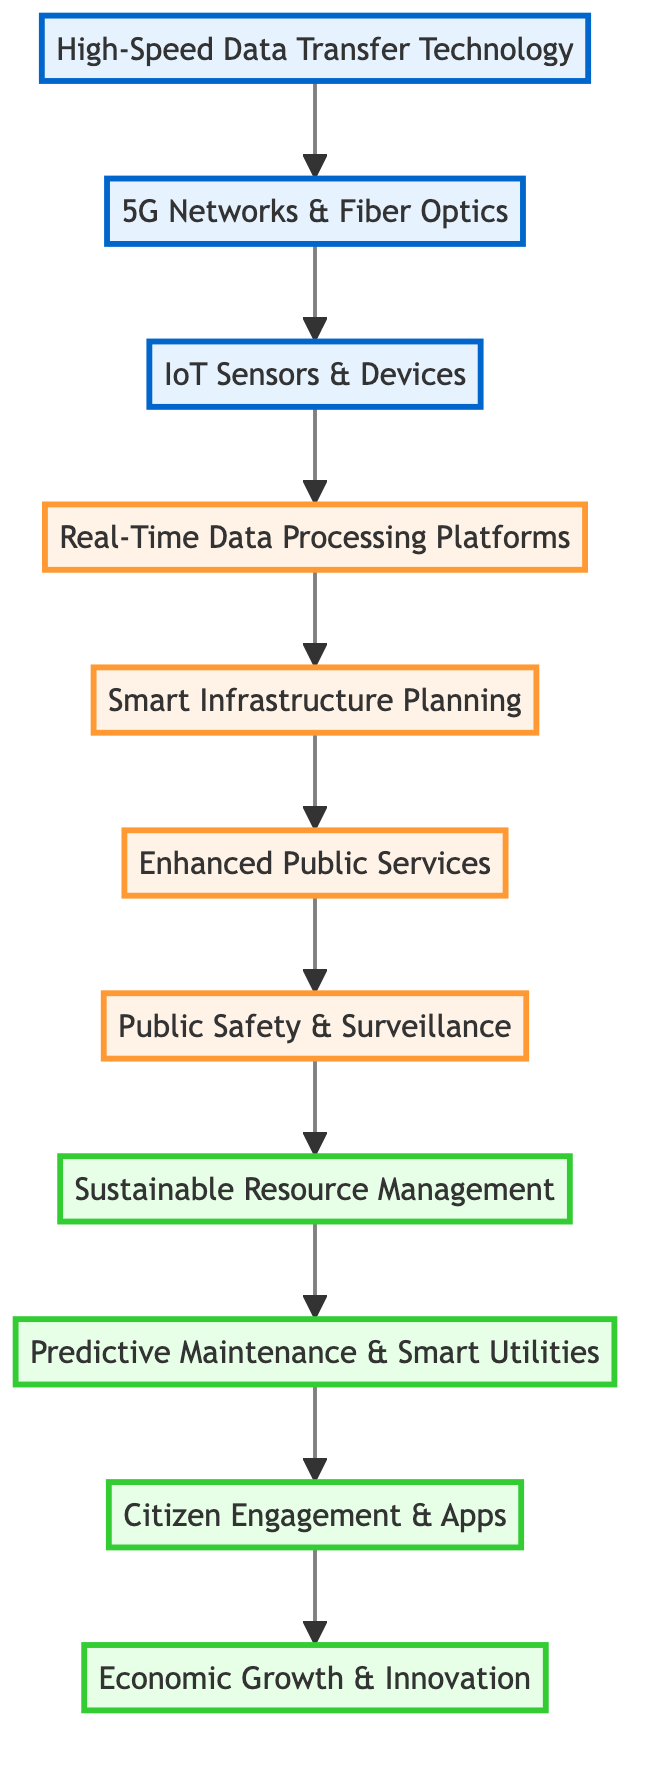What is the foundational infrastructure in the diagram? The foundational infrastructure is labeled as "High-Speed Data Transfer Technology." It appears at the bottom level of the diagram, indicating its primary role in supporting subsequent layers.
Answer: High-Speed Data Transfer Technology Which level connects "IoT Sensors & Devices" to "Real-Time Data Processing Platforms"? The level that connects these two nodes is level 3 to level 4. The flow from "IoT Sensors & Devices" leads to "Real-Time Data Processing Platforms" directly above it in the diagram.
Answer: 3 to 4 How many nodes represent public services directly? The nodes that represent public services directly are "Enhanced Public Services," "Public Safety & Surveillance," and "Citizen Engagement & Apps," totaling three nodes in this context.
Answer: 3 What is the last node in the flowchart, indicating the ultimate impact of advancements in smart cities? The last node in the flowchart is "Economic Growth & Innovation," representing the culmination of all the advancements through the layers of the diagram.
Answer: Economic Growth & Innovation Which two nodes are directly connected to "Sustainable Resource Management"? The two nodes directly connected to "Sustainable Resource Management" are "Public Safety & Surveillance" and "Predictive Maintenance & Smart Utilities." These are the immediate nodes above and below in the diagram, showing their sequential relationship.
Answer: Public Safety & Surveillance, Predictive Maintenance & Smart Utilities Explain the relationship between "Real-Time Data Processing Platforms" and "Smart Infrastructure Planning." "Real-Time Data Processing Platforms" supports "Smart Infrastructure Planning" by providing the necessary processed data for more informed decision-making in urban planning. This connection shows the dependency of planning on real-time data analytics.
Answer: Data-driven decision-making Which layer uses predictive analytics for maintenance? The layer that uses predictive analytics for maintenance is "Predictive Maintenance & Smart Utilities," indicating its focus on maintaining city utilities infrastructure efficiently through data-driven insights.
Answer: Predictive Maintenance & Smart Utilities What common technology is essential for high data transmission in smart cities? The common technology essential for high data transmission is "5G Networks & Fiber Optics," as indicated in the diagram's second layer supporting high bandwidth applications.
Answer: 5G Networks & Fiber Optics Which element primarily focuses on citizen interaction and engagement? The element that primarily focuses on citizen interaction and engagement is "Citizen Engagement & Apps," which highlights the importance of mobile applications for community participation and communication.
Answer: Citizen Engagement & Apps 